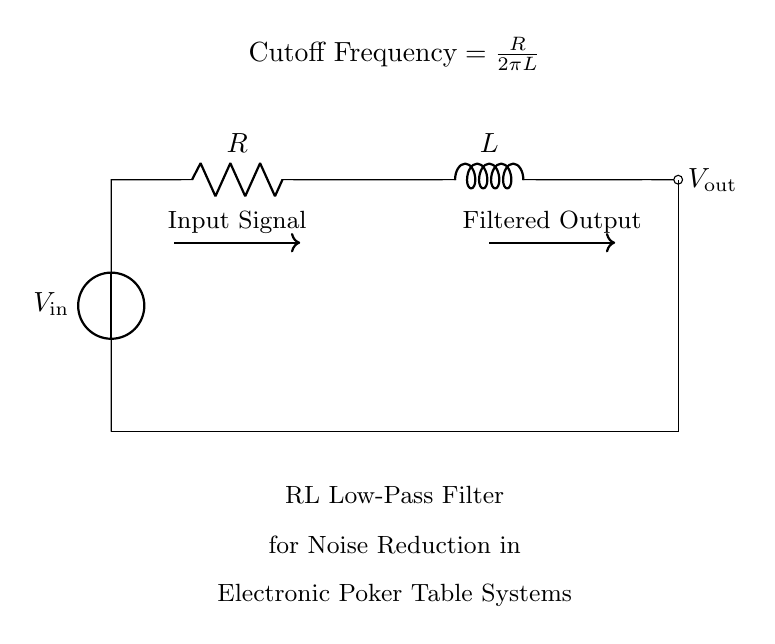What is the input voltage of this circuit? The input voltage is represented by the voltage source labeled V_input, which is at the leftmost part of the circuit diagram.
Answer: V_input What does the resistor do in this RL circuit? The resistor in an RL circuit limits the current and influences the cutoff frequency of the filter. It works in conjunction with the inductor to form a low-pass filter for noise reduction.
Answer: Limits current What is the role of the inductor in this circuit? The inductor stores energy in a magnetic field when current flows through it and helps filter out high-frequency noise, allowing only lower frequencies to pass.
Answer: Filters high frequency What is the cutoff frequency formula given in the diagram? The formula provided in the diagram shows how the cutoff frequency is calculated as R divided by two pi times L, indicating the relationship between resistance, inductance, and frequency.
Answer: R over 2πL How does increasing the resistance affect the cutoff frequency? Increasing the resistance will increase the cutoff frequency, allowing the filter to pass higher frequencies, as seen in the formula. This affects how the circuit responds to noise.
Answer: Increases cutoff frequency What is the output voltage in the context of this circuit? The output voltage, labeled V_out, indicates the voltage level across the load or the output of the circuit, which reflects the filtered signal after passing through the resistor and inductor.
Answer: V_out 